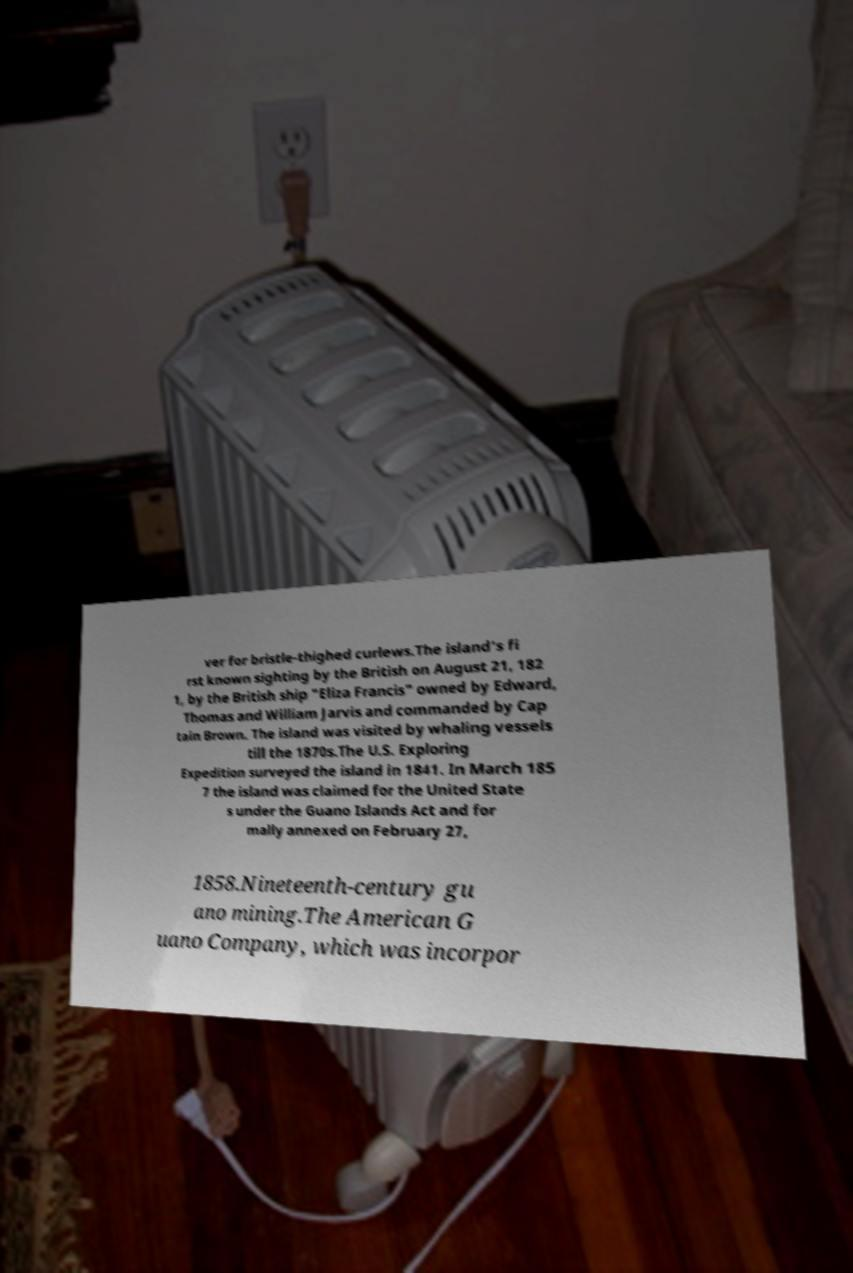Can you accurately transcribe the text from the provided image for me? ver for bristle-thighed curlews.The island's fi rst known sighting by the British on August 21, 182 1, by the British ship "Eliza Francis" owned by Edward, Thomas and William Jarvis and commanded by Cap tain Brown. The island was visited by whaling vessels till the 1870s.The U.S. Exploring Expedition surveyed the island in 1841. In March 185 7 the island was claimed for the United State s under the Guano Islands Act and for mally annexed on February 27, 1858.Nineteenth-century gu ano mining.The American G uano Company, which was incorpor 